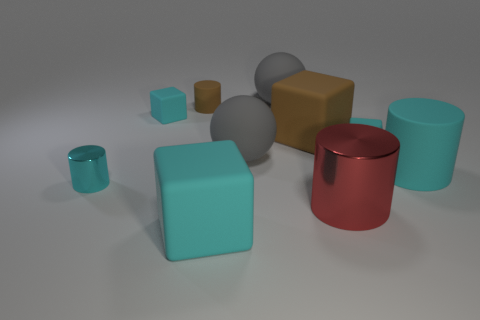Subtract all cyan blocks. How many were subtracted if there are1cyan blocks left? 2 Subtract all brown cylinders. How many cyan cubes are left? 3 Subtract 1 cylinders. How many cylinders are left? 3 Subtract all big metallic cylinders. How many cylinders are left? 3 Subtract all red cubes. Subtract all purple cylinders. How many cubes are left? 4 Subtract all balls. How many objects are left? 8 Add 2 large brown matte objects. How many large brown matte objects exist? 3 Subtract 1 brown cylinders. How many objects are left? 9 Subtract all tiny metallic objects. Subtract all tiny blocks. How many objects are left? 7 Add 3 large red shiny things. How many large red shiny things are left? 4 